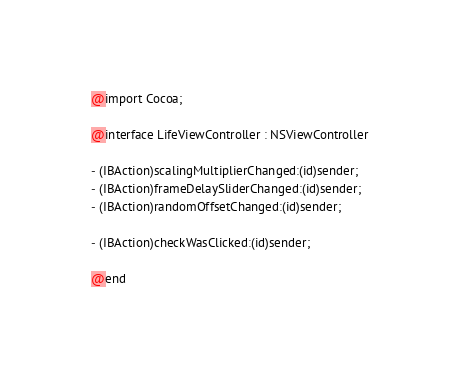Convert code to text. <code><loc_0><loc_0><loc_500><loc_500><_C_>
@import Cocoa;

@interface LifeViewController : NSViewController

- (IBAction)scalingMultiplierChanged:(id)sender;
- (IBAction)frameDelaySliderChanged:(id)sender;
- (IBAction)randomOffsetChanged:(id)sender;

- (IBAction)checkWasClicked:(id)sender;

@end
</code> 